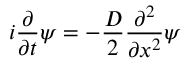Convert formula to latex. <formula><loc_0><loc_0><loc_500><loc_500>i \frac { \partial } { \partial t } \psi = - \frac { D } { 2 } \frac { \partial ^ { 2 } } { \partial x ^ { 2 } } \psi</formula> 